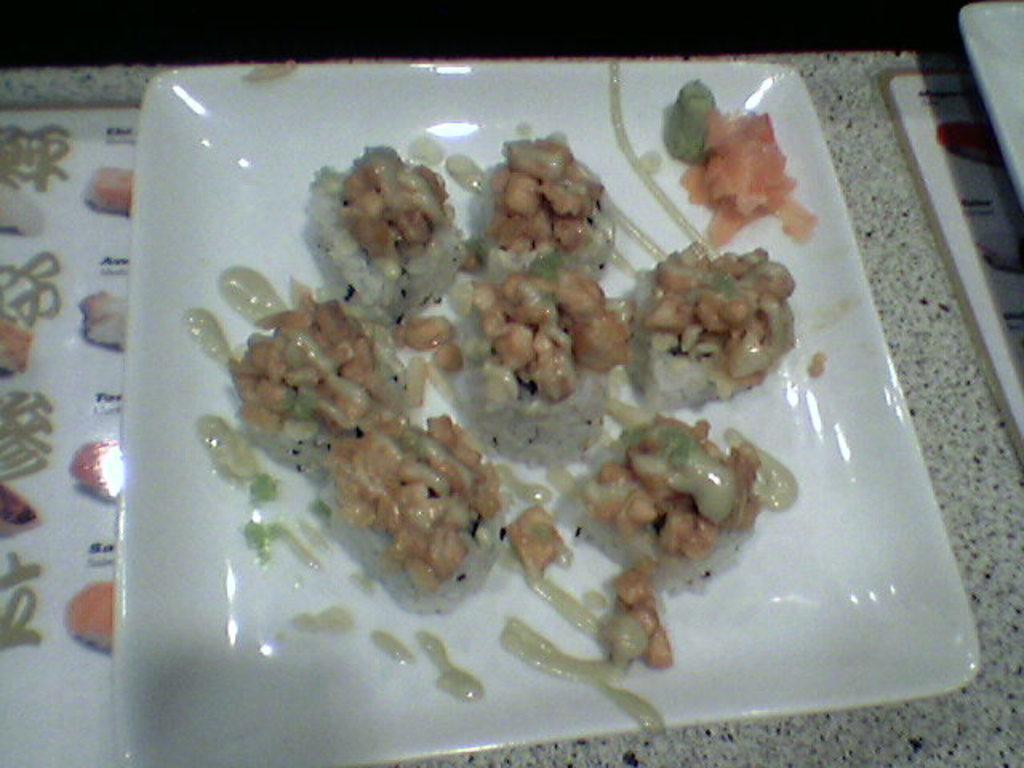How would you summarize this image in a sentence or two? In this picture we can see some food and sauce on a white plate kept on a wooden table. 